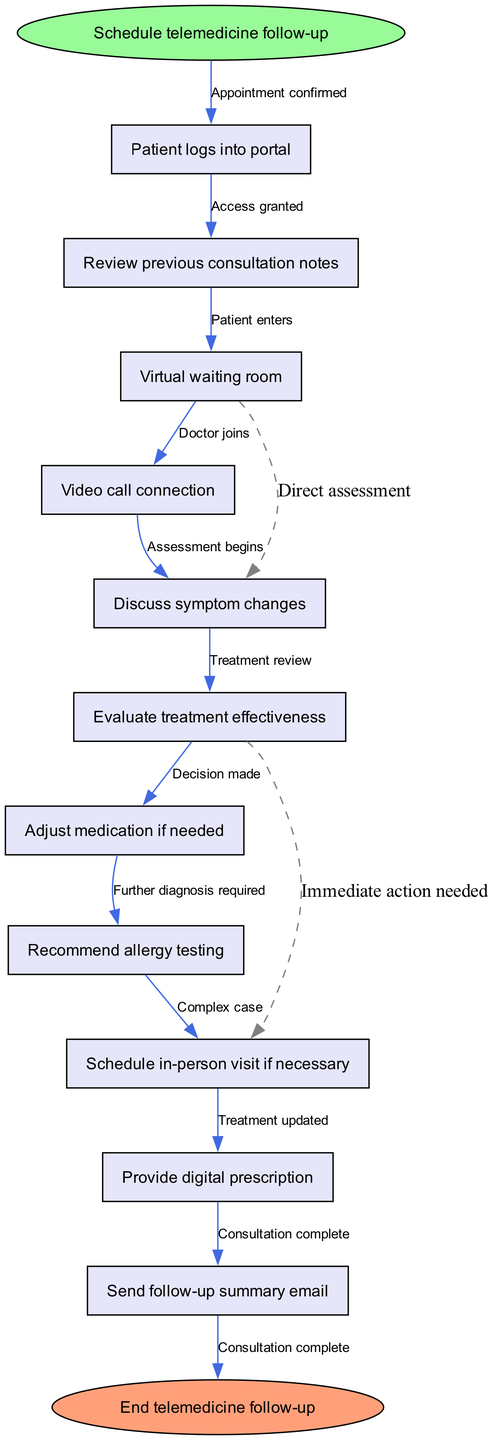What is the starting point of the telemedicine follow-up workflow? The starting point is indicated at the top of the diagram, labeled as "Schedule telemedicine follow-up." This node serves as the entry into the workflow process, focusing on the initial appointment scheduling aspect.
Answer: Schedule telemedicine follow-up How many nodes are present in the diagram? The diagram contains a total of 11 nodes, which includes the start and end points along with the intermediary steps in the telemedicine follow-up process. Each step is visually represented as a distinct node.
Answer: 11 What is the last step before ending the telemedicine follow-up? The last step in the flow before reaching the end node is the "Send follow-up summary email." This is the penultimate action completed in the workflow right before concluding the consultation process.
Answer: Send follow-up summary email Which step comes after "Video call connection"? In the workflow, "Discuss symptom changes" immediately follows "Video call connection." This indicates that after establishing a video call, the next action is to address any symptom changes with the patient.
Answer: Discuss symptom changes What are the two paths that can be taken after the "Evaluate treatment effectiveness"? Two diverging paths are shown after "Evaluate treatment effectiveness." The first is to adjust the treatment if needed, and the second involves recommending further allergy testing. This showcases a choice based on the evaluation results.
Answer: Adjust medication if needed, Recommend allergy testing What does the dashed line from "Virtual waiting room" to "Evaluate treatment effectiveness" signify? The dashed line indicates a parallel path that suggests a direct assessment could be made without waiting for the subsequent steps in the workflow, implying more flexibility in the process based on the specific situation.
Answer: Direct assessment If a patient needs an in-person visit, which step follows that decision? If an in-person visit is required, it is scheduled after the decision made in the step "Adjust medication if needed". This shows how specific actions lead to further clinical evaluations and subsequent scheduling needs.
Answer: Schedule in-person visit if necessary What action is taken if the treatment effectiveness is deemed inadequate? If the treatment effectiveness is not satisfactory, the flowchart indicates that the next necessary action is to "Adjust medication if needed." This reflects the process's responsiveness to patient care needs based on ongoing evaluations.
Answer: Adjust medication if needed 